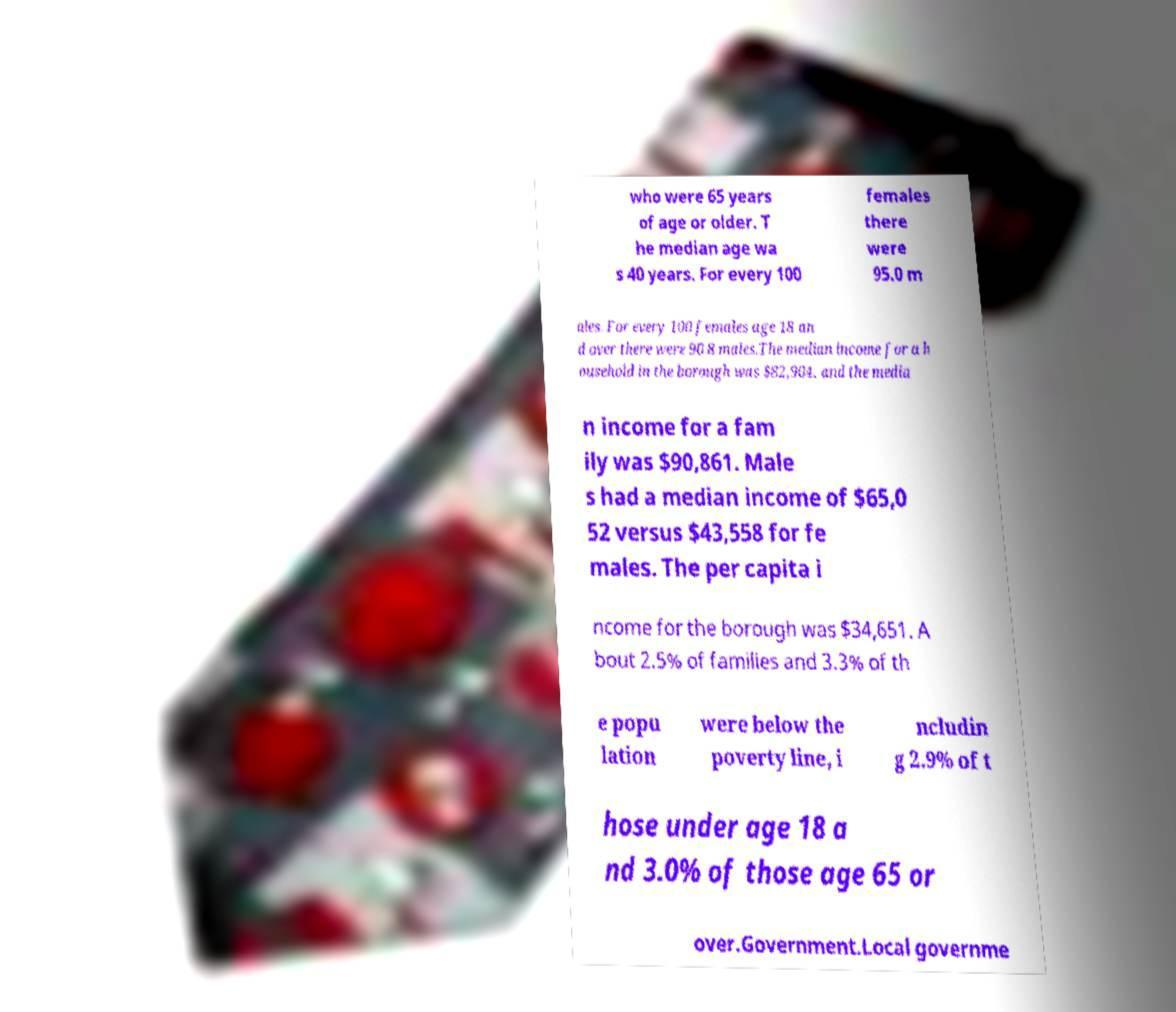What messages or text are displayed in this image? I need them in a readable, typed format. who were 65 years of age or older. T he median age wa s 40 years. For every 100 females there were 95.0 m ales. For every 100 females age 18 an d over there were 90.8 males.The median income for a h ousehold in the borough was $82,904, and the media n income for a fam ily was $90,861. Male s had a median income of $65,0 52 versus $43,558 for fe males. The per capita i ncome for the borough was $34,651. A bout 2.5% of families and 3.3% of th e popu lation were below the poverty line, i ncludin g 2.9% of t hose under age 18 a nd 3.0% of those age 65 or over.Government.Local governme 